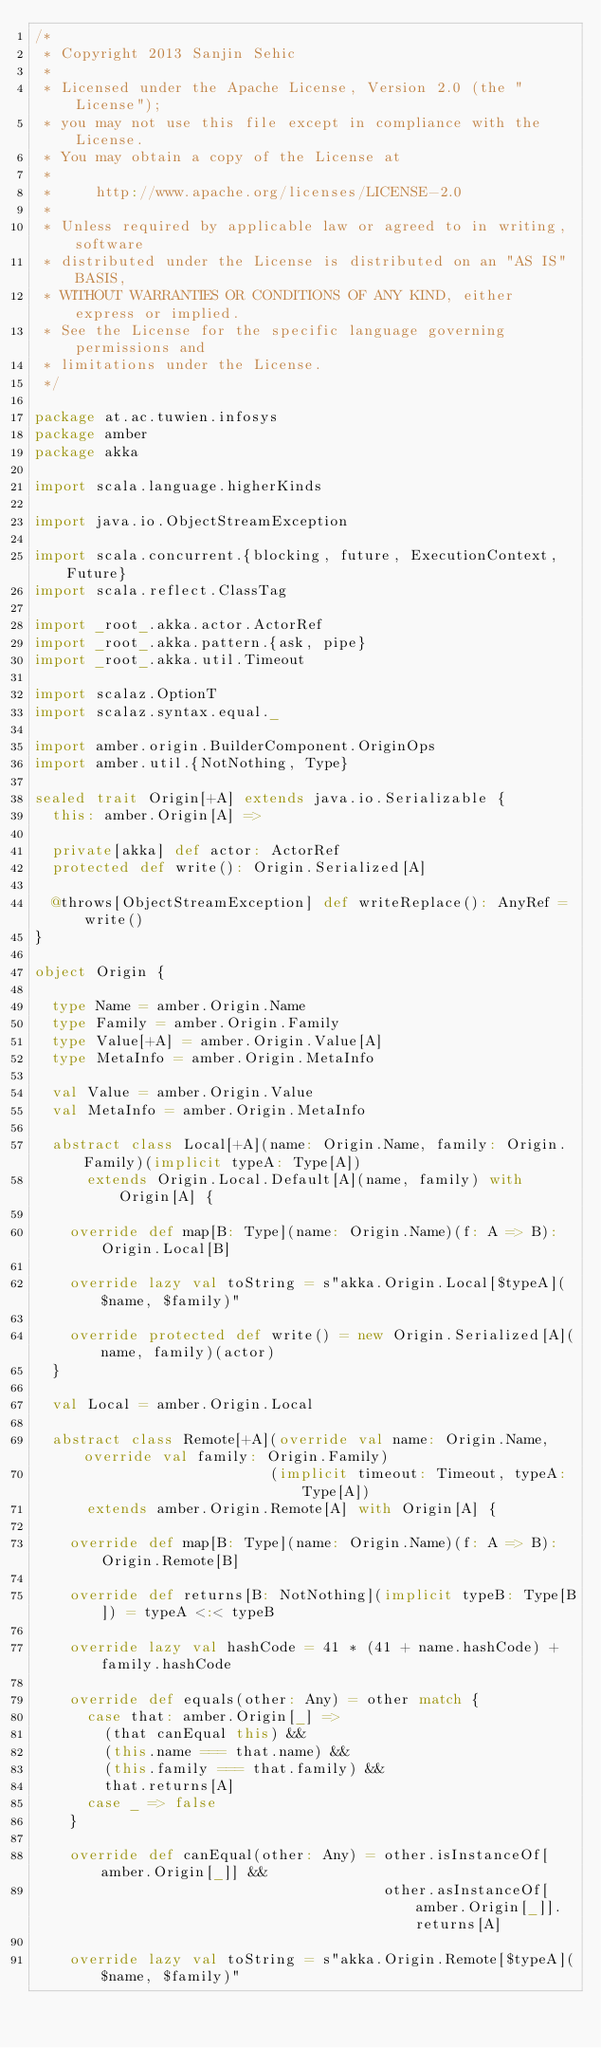Convert code to text. <code><loc_0><loc_0><loc_500><loc_500><_Scala_>/*
 * Copyright 2013 Sanjin Sehic
 *
 * Licensed under the Apache License, Version 2.0 (the "License");
 * you may not use this file except in compliance with the License.
 * You may obtain a copy of the License at
 *
 *     http://www.apache.org/licenses/LICENSE-2.0
 *
 * Unless required by applicable law or agreed to in writing, software
 * distributed under the License is distributed on an "AS IS" BASIS,
 * WITHOUT WARRANTIES OR CONDITIONS OF ANY KIND, either express or implied.
 * See the License for the specific language governing permissions and
 * limitations under the License.
 */

package at.ac.tuwien.infosys
package amber
package akka

import scala.language.higherKinds

import java.io.ObjectStreamException

import scala.concurrent.{blocking, future, ExecutionContext, Future}
import scala.reflect.ClassTag

import _root_.akka.actor.ActorRef
import _root_.akka.pattern.{ask, pipe}
import _root_.akka.util.Timeout

import scalaz.OptionT
import scalaz.syntax.equal._

import amber.origin.BuilderComponent.OriginOps
import amber.util.{NotNothing, Type}

sealed trait Origin[+A] extends java.io.Serializable {
  this: amber.Origin[A] =>

  private[akka] def actor: ActorRef
  protected def write(): Origin.Serialized[A]

  @throws[ObjectStreamException] def writeReplace(): AnyRef = write()
}

object Origin {

  type Name = amber.Origin.Name
  type Family = amber.Origin.Family
  type Value[+A] = amber.Origin.Value[A]
  type MetaInfo = amber.Origin.MetaInfo

  val Value = amber.Origin.Value
  val MetaInfo = amber.Origin.MetaInfo

  abstract class Local[+A](name: Origin.Name, family: Origin.Family)(implicit typeA: Type[A])
      extends Origin.Local.Default[A](name, family) with Origin[A] {

    override def map[B: Type](name: Origin.Name)(f: A => B): Origin.Local[B]

    override lazy val toString = s"akka.Origin.Local[$typeA]($name, $family)"

    override protected def write() = new Origin.Serialized[A](name, family)(actor)
  }

  val Local = amber.Origin.Local

  abstract class Remote[+A](override val name: Origin.Name, override val family: Origin.Family)
                           (implicit timeout: Timeout, typeA: Type[A])
      extends amber.Origin.Remote[A] with Origin[A] {

    override def map[B: Type](name: Origin.Name)(f: A => B): Origin.Remote[B]

    override def returns[B: NotNothing](implicit typeB: Type[B]) = typeA <:< typeB

    override lazy val hashCode = 41 * (41 + name.hashCode) + family.hashCode

    override def equals(other: Any) = other match {
      case that: amber.Origin[_] =>
        (that canEqual this) &&
        (this.name === that.name) &&
        (this.family === that.family) &&
        that.returns[A]
      case _ => false
    }

    override def canEqual(other: Any) = other.isInstanceOf[amber.Origin[_]] &&
                                        other.asInstanceOf[amber.Origin[_]].returns[A]

    override lazy val toString = s"akka.Origin.Remote[$typeA]($name, $family)"
</code> 